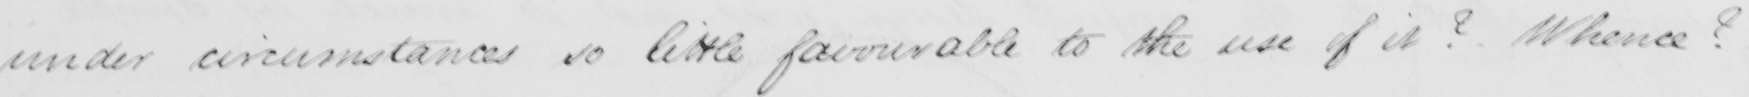Transcribe the text shown in this historical manuscript line. under circumstances so little favourable to the use of it ?  Whence ? 